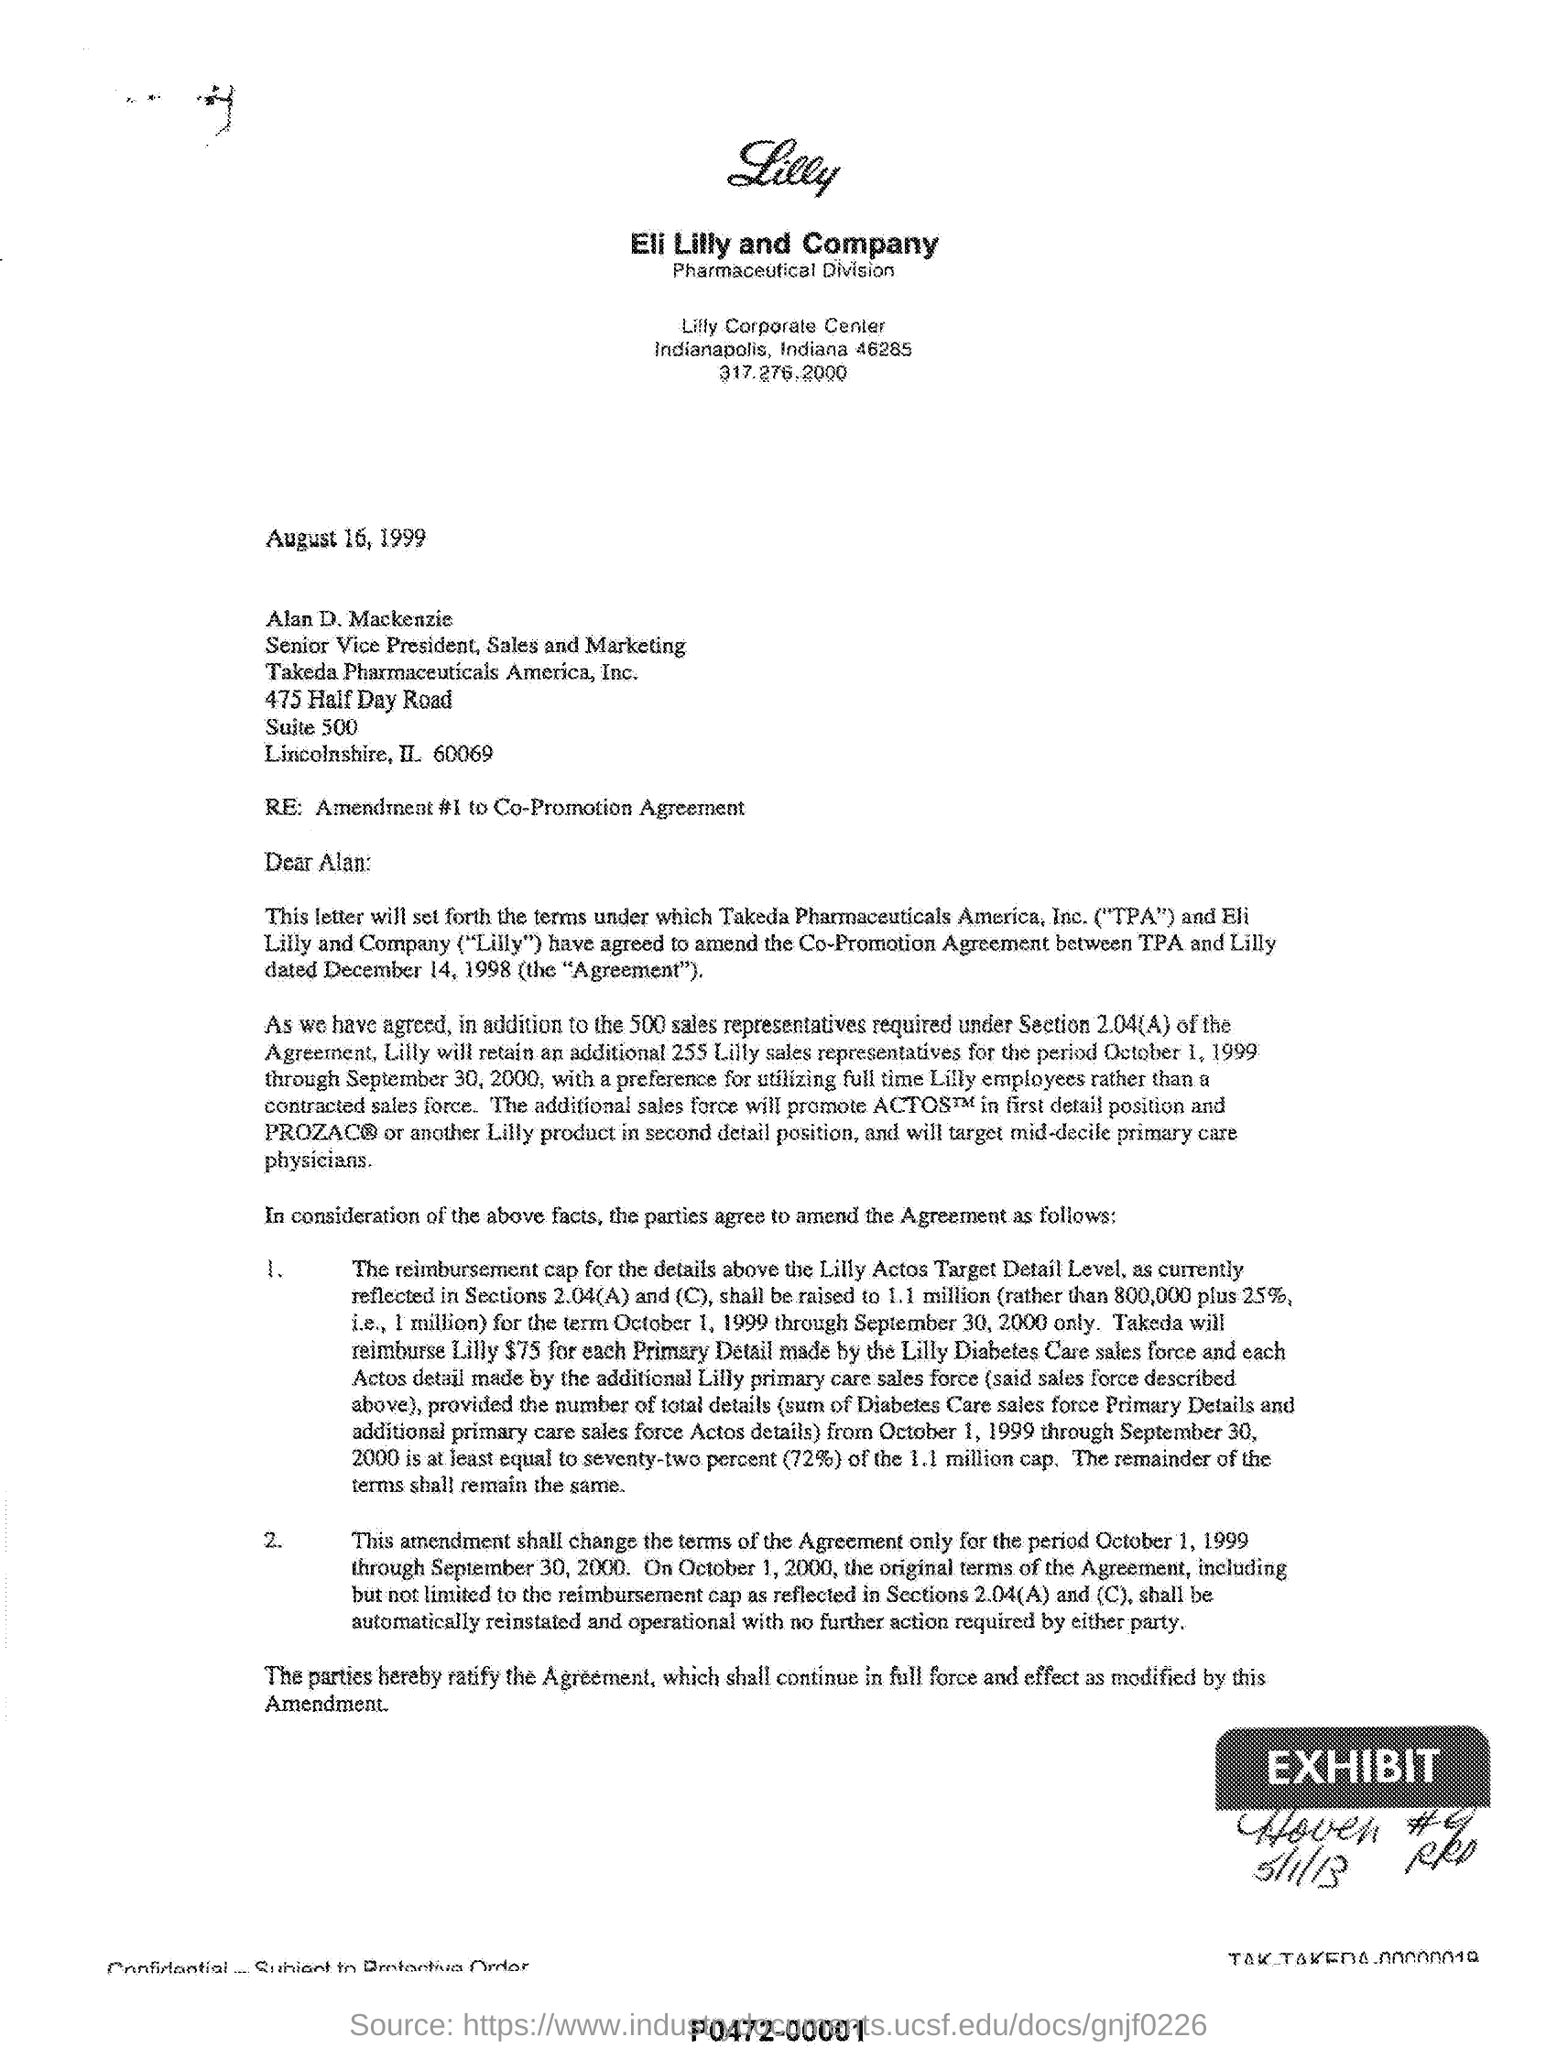What is the date mentioned?
Offer a very short reply. August 16, 1999. To whom is this letter addressed?
Provide a short and direct response. Alan D. Mackenzie. What is the full form of TPA?
Ensure brevity in your answer.  Takeda Pharmaceuticals America, Inc. Which two companies have agreed to amend the Co-Promotion Agreement?
Ensure brevity in your answer.  Takeda Pharmaceuticals America, Inc. ("TPA") and Eli Lilly and Company ("Lilly"). 